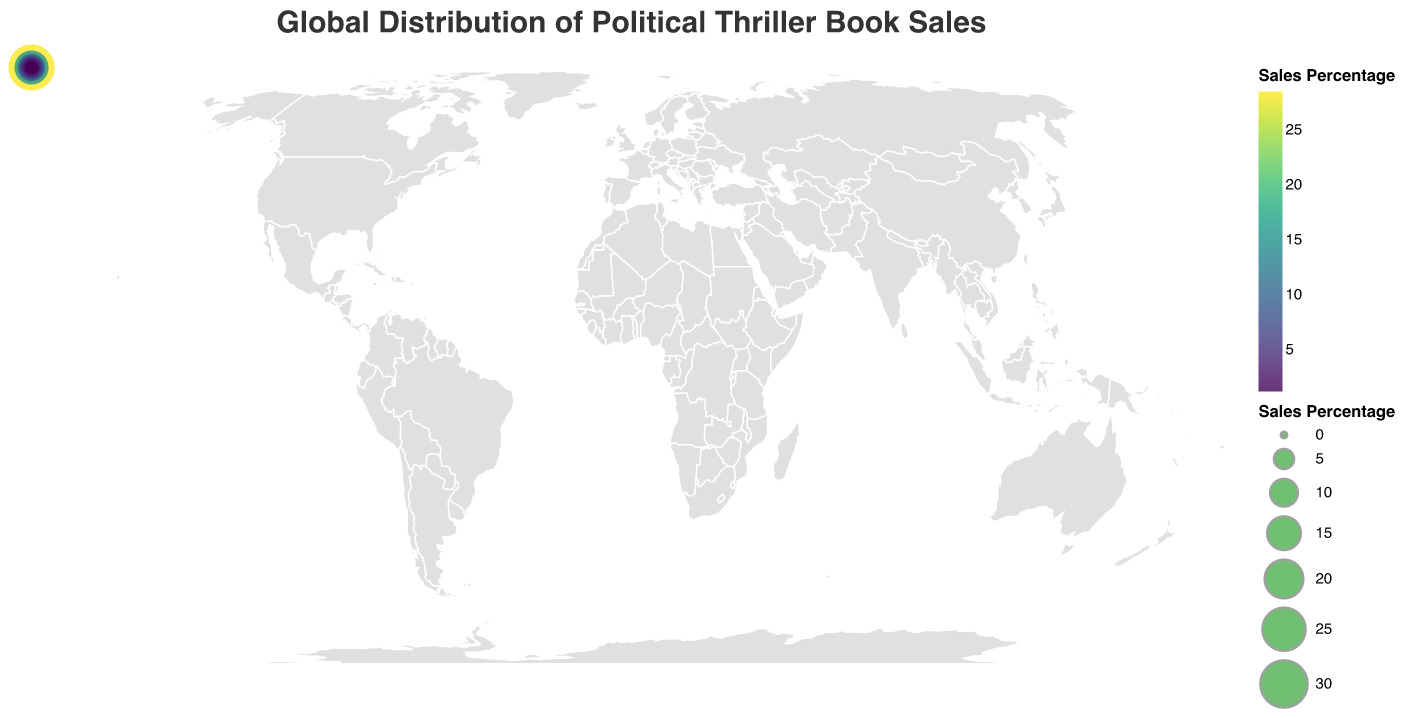What is the title of the figure? The title of the figure is prominently displayed at the top and reads "Global Distribution of Political Thriller Book Sales."
Answer: Global Distribution of Political Thriller Book Sales Which country has the highest percentage of political thriller book sales? The United States has the highest sales percentage, which can be identified by the largest circle and the highest value in the data.
Answer: United States How much is the sales percentage in Germany? By looking at Germany in the figure and checking its corresponding tooltip or size of the circle, the sales percentage is 9.7%.
Answer: 9.7% What is the combined sales percentage of the United States and the United Kingdom? The sales percentages for the United States and the United Kingdom are 28.5% and 15.2%, respectively. Adding these values gives a total of 43.7%.
Answer: 43.7% Which two countries have the closest sales percentages? By comparing the values, Ireland (1.3%) and New Zealand (1.2%) have the closest sales percentages.
Answer: Ireland and New Zealand What is the total sales percentage of all the countries combined? Summing up all the sales percentages provided in the dataset: 28.5 + 15.2 + 9.7 + 7.3 + 6.8 + 5.9 + 4.6 + 3.8 + 3.2 + 2.9 + 2.5 + 2.1 + 1.8 + 1.7 + 1.5 + 1.3 + 1.2 = 100%.
Answer: 100% Among Australia, South Africa, and New Zealand, which country has the highest sales percentage? Comparing the sales percentages of the three countries: Australia (6.8%), South Africa (1.5%), and New Zealand (1.2%), Australia has the highest percentage.
Answer: Australia How much higher is the sales percentage of Japan compared to Ireland? Japan's sales percentage is 4.6%, and Ireland's is 1.3%. The difference is 4.6% - 1.3% = 3.3%.
Answer: 3.3% Which continents are represented in the distribution? Analyzing the data and considering the countries listed, the represented continents are North America (United States, Canada), Europe (United Kingdom, Germany, France, Italy, Spain, Netherlands, Sweden, Russia, Ireland), Asia (Japan, India, Russia), South America (Brazil), Africa (South Africa), and Oceania (Australia, New Zealand).
Answer: North America, Europe, Asia, South America, Africa, Oceania How does Canada’s sales percentage compare with France’s? Canada's sales percentage is 7.3%, while France's is 5.9%. Canada has a higher sales percentage than France.
Answer: Canada is higher 